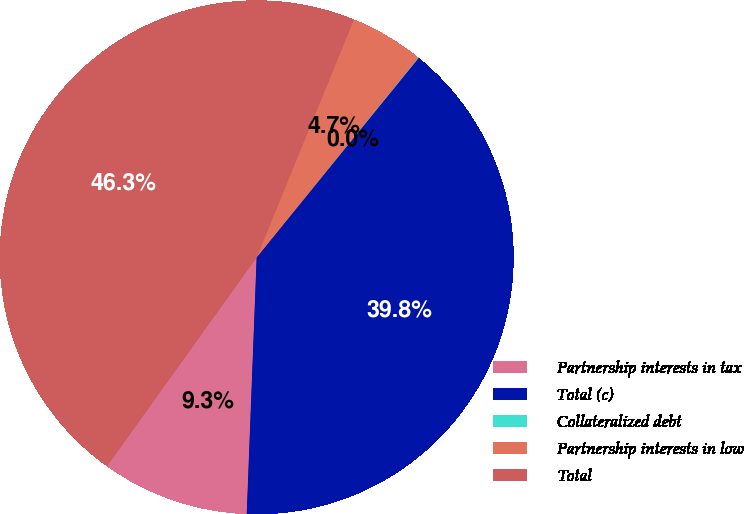Convert chart to OTSL. <chart><loc_0><loc_0><loc_500><loc_500><pie_chart><fcel>Partnership interests in tax<fcel>Total (c)<fcel>Collateralized debt<fcel>Partnership interests in low<fcel>Total<nl><fcel>9.28%<fcel>39.76%<fcel>0.03%<fcel>4.65%<fcel>46.28%<nl></chart> 